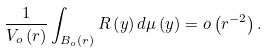<formula> <loc_0><loc_0><loc_500><loc_500>\frac { 1 } { V _ { o } \left ( r \right ) } \int _ { B _ { o } \left ( r \right ) } R \left ( y \right ) d \mu \left ( y \right ) = o \left ( r ^ { - 2 } \right ) .</formula> 